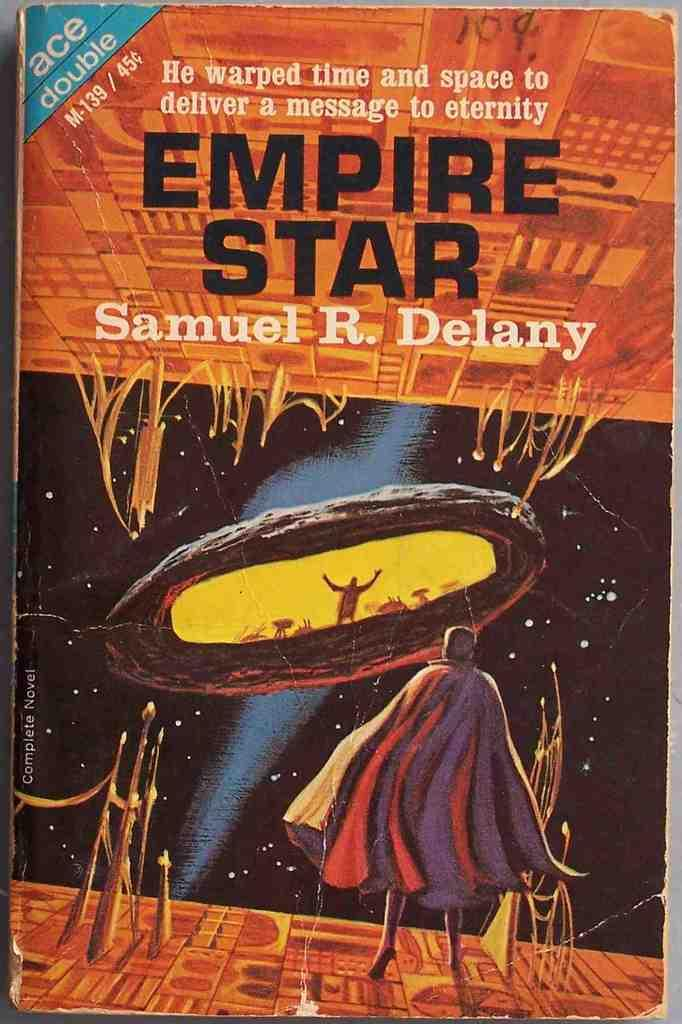<image>
Create a compact narrative representing the image presented. Ace double is the publisher of Empire Star. 